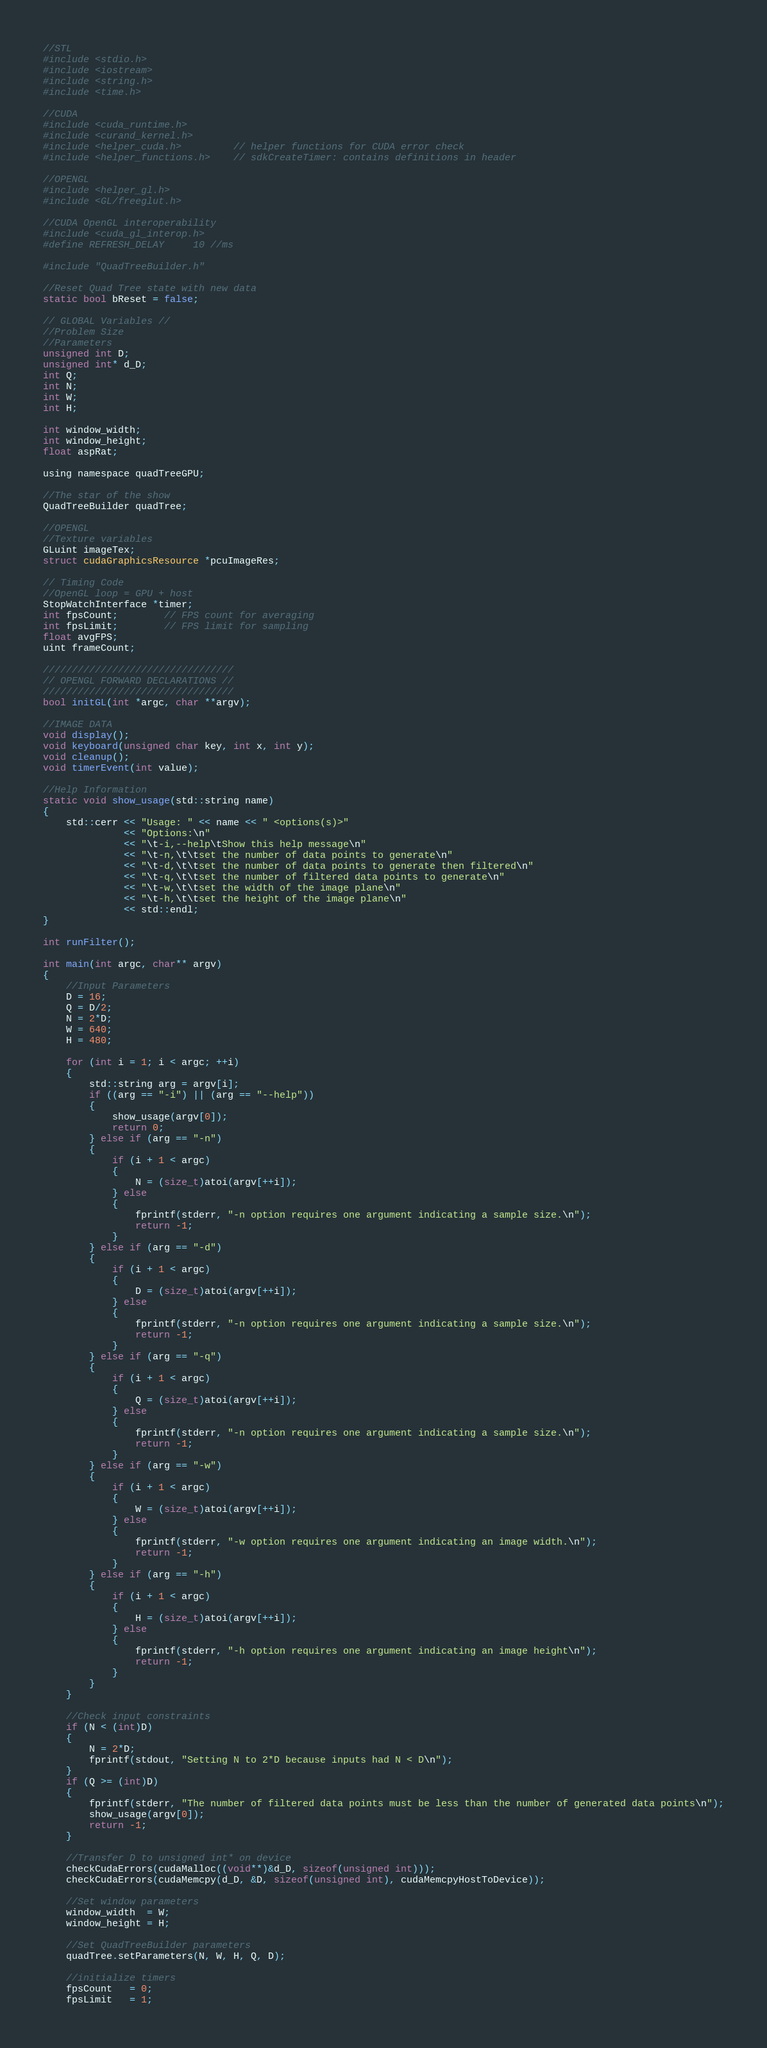Convert code to text. <code><loc_0><loc_0><loc_500><loc_500><_Cuda_>//STL
#include <stdio.h>
#include <iostream>
#include <string.h>
#include <time.h>

//CUDA
#include <cuda_runtime.h>
#include <curand_kernel.h>
#include <helper_cuda.h>         // helper functions for CUDA error check
#include <helper_functions.h>    // sdkCreateTimer: contains definitions in header

//OPENGL
#include <helper_gl.h>
#include <GL/freeglut.h>

//CUDA OpenGL interoperability
#include <cuda_gl_interop.h>
#define REFRESH_DELAY     10 //ms

#include "QuadTreeBuilder.h"

//Reset Quad Tree state with new data
static bool bReset = false;

// GLOBAL Variables //
//Problem Size
//Parameters
unsigned int D;
unsigned int* d_D;
int Q;
int N;
int W;
int H;

int window_width;
int window_height;
float aspRat;

using namespace quadTreeGPU;

//The star of the show
QuadTreeBuilder quadTree;

//OPENGL
//Texture variables
GLuint imageTex;
struct cudaGraphicsResource *pcuImageRes;

// Timing Code
//OpenGL loop = GPU + host
StopWatchInterface *timer;
int fpsCount;        // FPS count for averaging
int fpsLimit;        // FPS limit for sampling
float avgFPS;
uint frameCount;

/////////////////////////////////
// OPENGL FORWARD DECLARATIONS //
/////////////////////////////////
bool initGL(int *argc, char **argv);

//IMAGE DATA
void display();
void keyboard(unsigned char key, int x, int y);
void cleanup();
void timerEvent(int value);

//Help Information
static void show_usage(std::string name)
{
	std::cerr << "Usage: " << name << " <options(s)>"
			  << "Options:\n"
			  << "\t-i,--help\tShow this help message\n"
			  << "\t-n,\t\tset the number of data points to generate\n"
			  << "\t-d,\t\tset the number of data points to generate then filtered\n"
			  << "\t-q,\t\tset the number of filtered data points to generate\n"
			  << "\t-w,\t\tset the width of the image plane\n"
			  << "\t-h,\t\tset the height of the image plane\n"
			  << std::endl;
}

int runFilter();

int main(int argc, char** argv)
{
	//Input Parameters
	D = 16;
	Q = D/2;
	N = 2*D;
	W = 640;
	H = 480;

	for (int i = 1; i < argc; ++i)
	{
		std::string arg = argv[i];
		if ((arg == "-i") || (arg == "--help"))
		{
			show_usage(argv[0]);
			return 0;  
		} else if (arg == "-n")
		{
			if (i + 1 < argc)
			{
				N = (size_t)atoi(argv[++i]);
			} else
			{
				fprintf(stderr, "-n option requires one argument indicating a sample size.\n");
				return -1;
			}
		} else if (arg == "-d")
		{
			if (i + 1 < argc)
			{
				D = (size_t)atoi(argv[++i]);
			} else
			{
				fprintf(stderr, "-n option requires one argument indicating a sample size.\n");
				return -1;
			}
		} else if (arg == "-q")
		{
			if (i + 1 < argc)
			{
				Q = (size_t)atoi(argv[++i]);
			} else
			{
				fprintf(stderr, "-n option requires one argument indicating a sample size.\n");
				return -1;
			}
		} else if (arg == "-w")
		{
			if (i + 1 < argc)
			{
				W = (size_t)atoi(argv[++i]);
			} else
			{
				fprintf(stderr, "-w option requires one argument indicating an image width.\n");
				return -1;
			}
		} else if (arg == "-h")
		{
			if (i + 1 < argc)
			{
				H = (size_t)atoi(argv[++i]);
			} else
			{
				fprintf(stderr, "-h option requires one argument indicating an image height\n");
				return -1;
			}
		}
	}

	//Check input constraints
	if (N < (int)D)
	{
		N = 2*D;
		fprintf(stdout, "Setting N to 2*D because inputs had N < D\n");
	}
	if (Q >= (int)D)
	{
		fprintf(stderr, "The number of filtered data points must be less than the number of generated data points\n");
		show_usage(argv[0]);
		return -1;
	}

	//Transfer D to unsigned int* on device
	checkCudaErrors(cudaMalloc((void**)&d_D, sizeof(unsigned int)));
	checkCudaErrors(cudaMemcpy(d_D, &D, sizeof(unsigned int), cudaMemcpyHostToDevice));

	//Set window parameters
	window_width  = W;
	window_height = H;

	//Set QuadTreeBuilder parameters
	quadTree.setParameters(N, W, H, Q, D);

	//initialize timers
	fpsCount   = 0;
	fpsLimit   = 1;</code> 